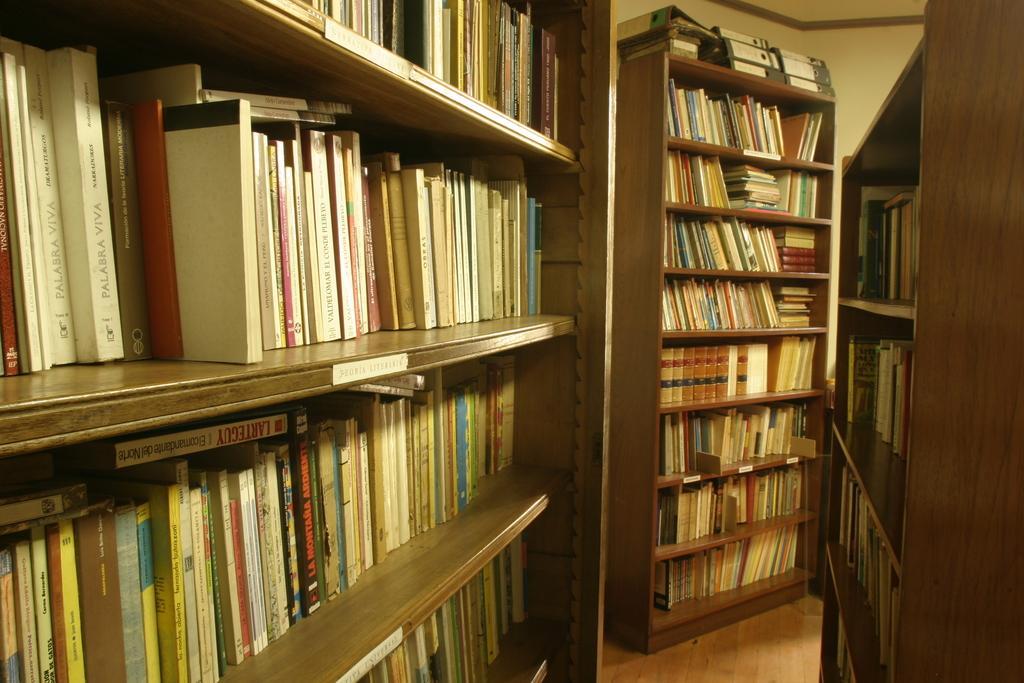Can you describe this image briefly? In this image we can see books arranged in the cupboards. 